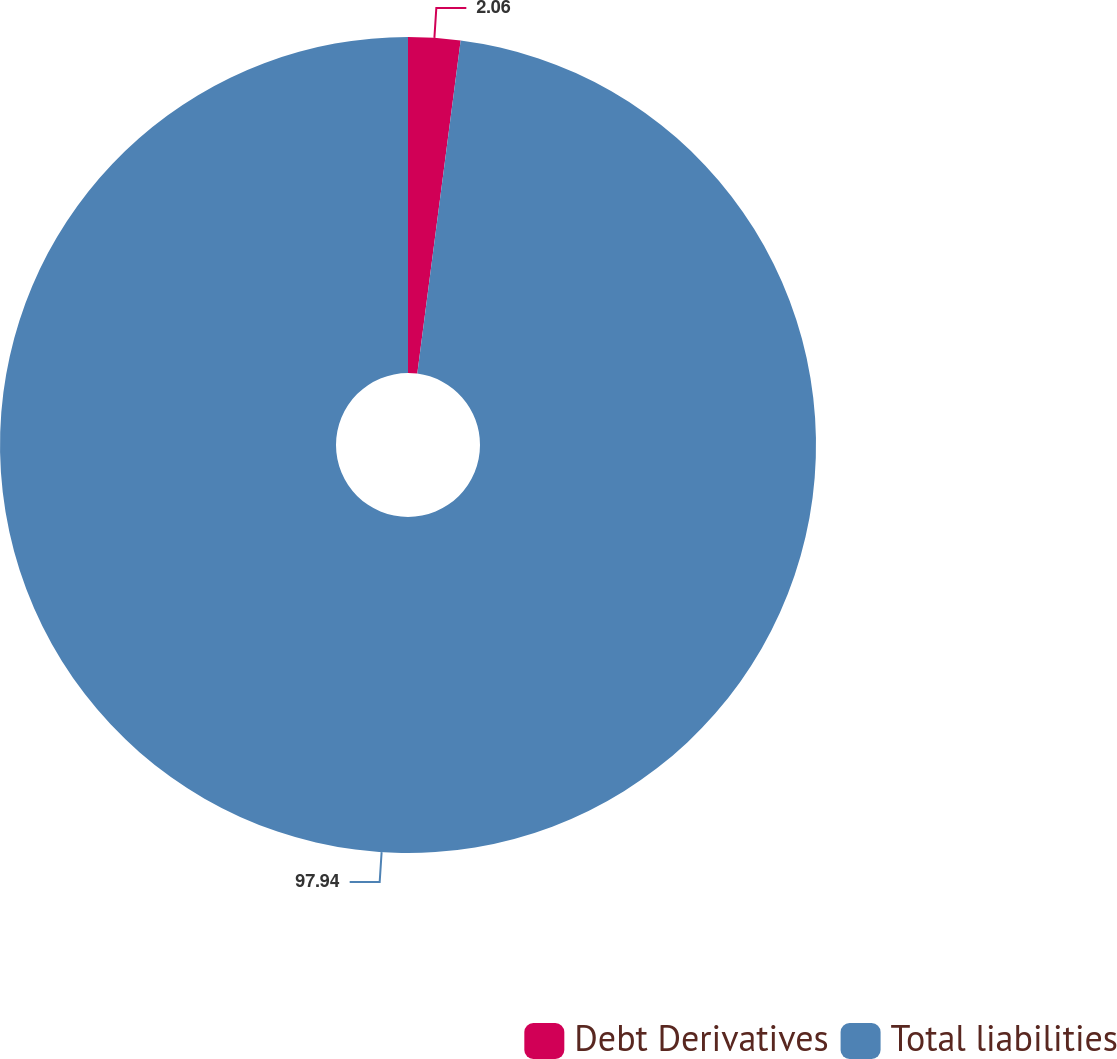Convert chart. <chart><loc_0><loc_0><loc_500><loc_500><pie_chart><fcel>Debt Derivatives<fcel>Total liabilities<nl><fcel>2.06%<fcel>97.94%<nl></chart> 